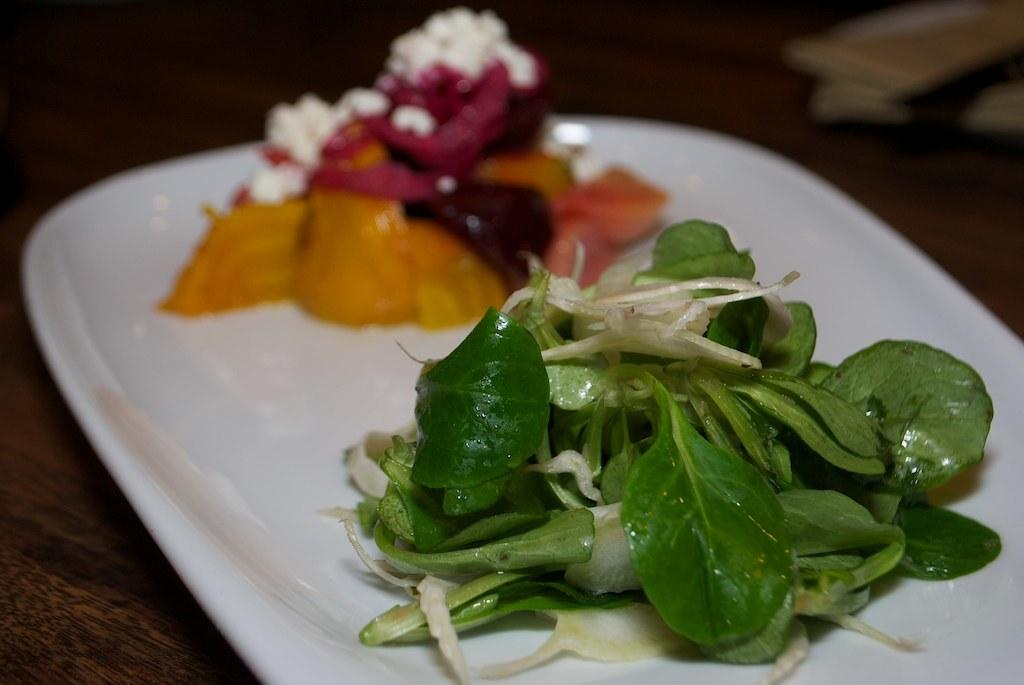What is on the plate that is visible in the image? There are food items on a plate in the image. What color is the plate? The plate is white. Can you describe the background of the image? The background of the image is blurred. What type of wave can be seen crashing on the shore in the image? There is no wave or shore present in the image; it only features a plate with food items and a blurred background. 